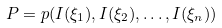Convert formula to latex. <formula><loc_0><loc_0><loc_500><loc_500>P = p ( I ( \xi _ { 1 } ) , I ( \xi _ { 2 } ) , \dots , I ( \xi _ { n } ) )</formula> 